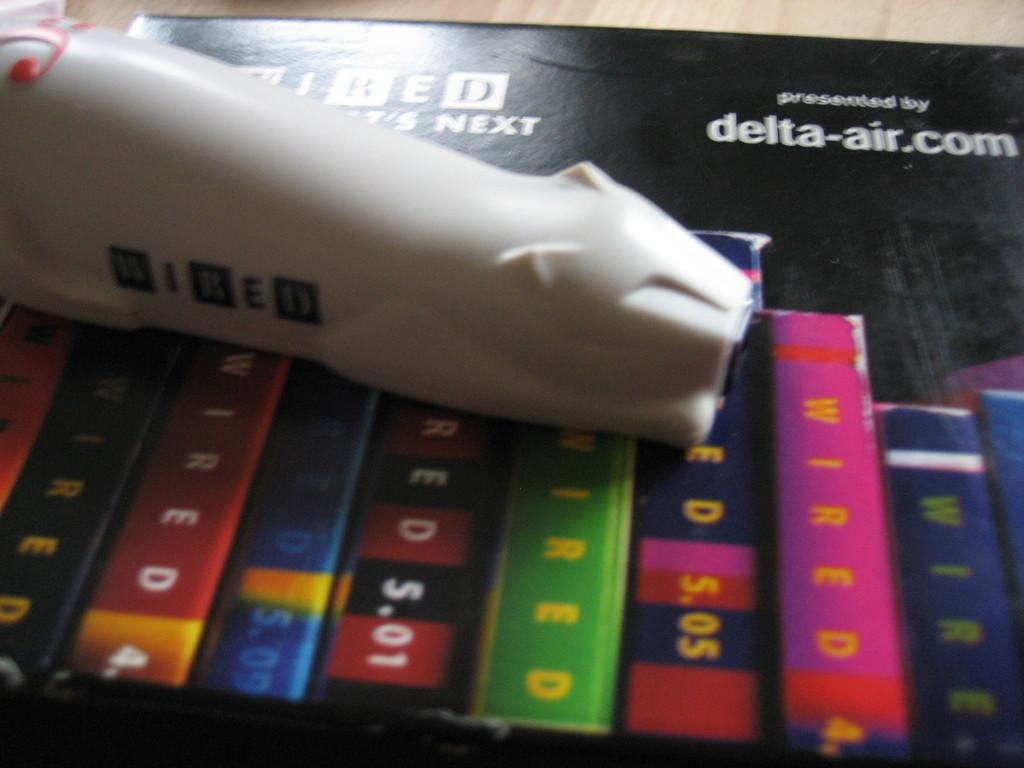<image>
Give a short and clear explanation of the subsequent image. Colorful books with Wired on the spines are shown on a black poster. 